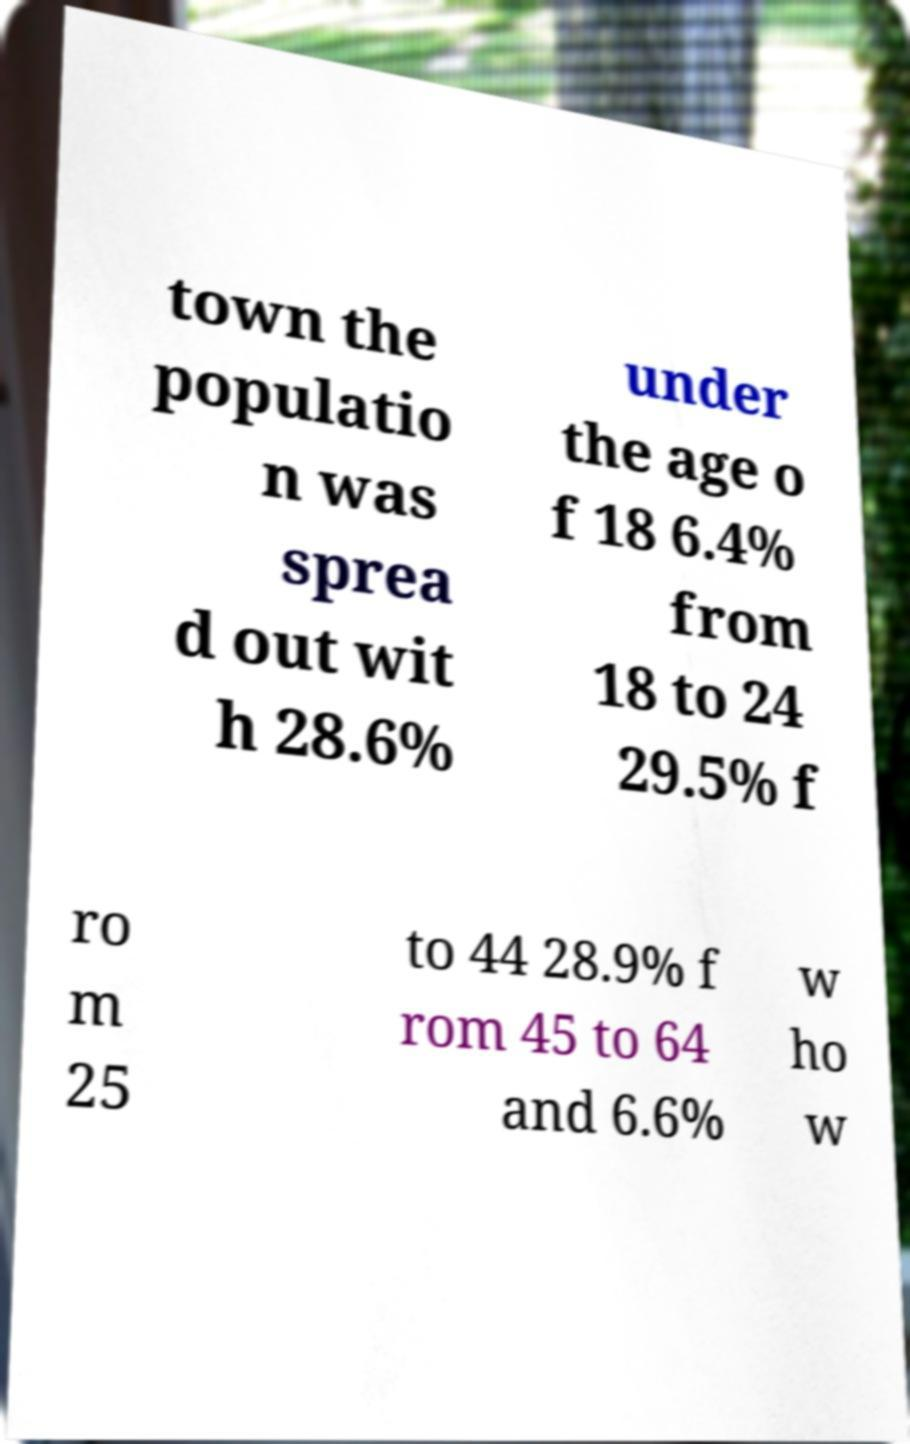There's text embedded in this image that I need extracted. Can you transcribe it verbatim? town the populatio n was sprea d out wit h 28.6% under the age o f 18 6.4% from 18 to 24 29.5% f ro m 25 to 44 28.9% f rom 45 to 64 and 6.6% w ho w 